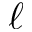<formula> <loc_0><loc_0><loc_500><loc_500>\ell</formula> 